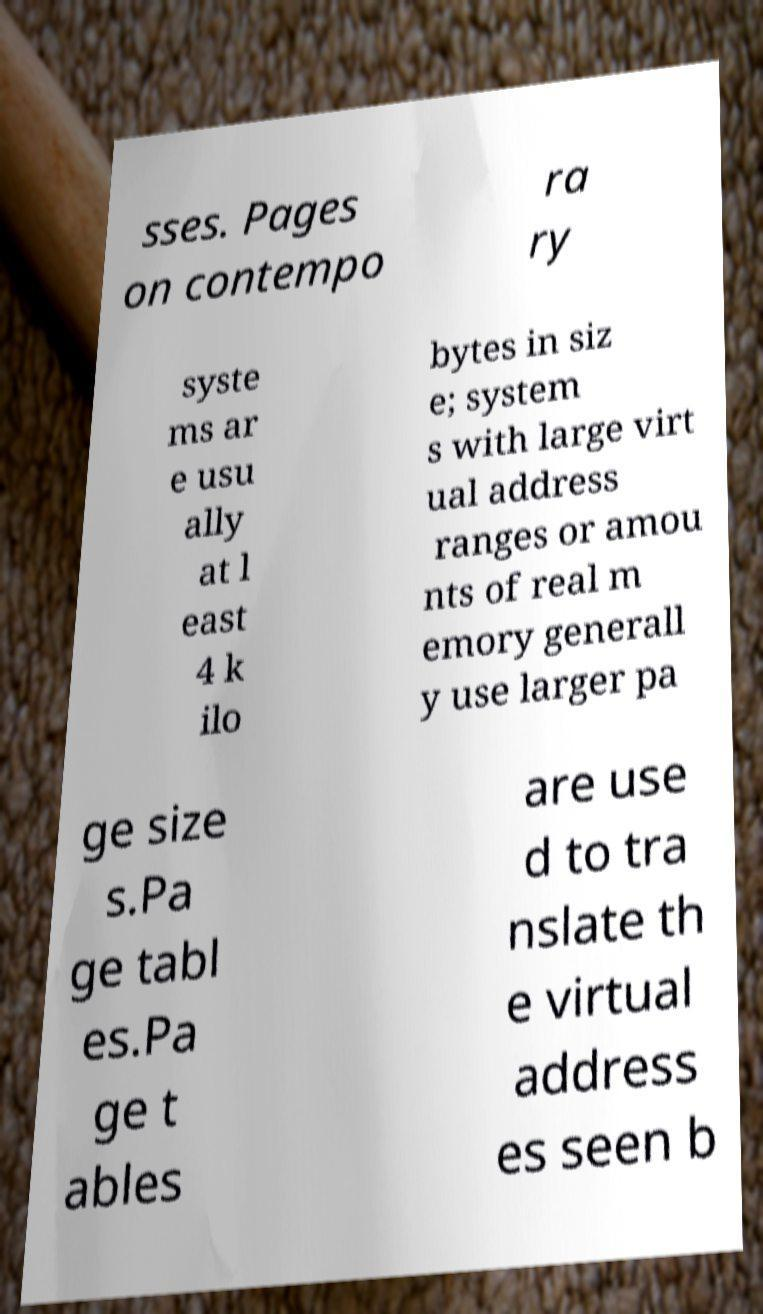Can you accurately transcribe the text from the provided image for me? sses. Pages on contempo ra ry syste ms ar e usu ally at l east 4 k ilo bytes in siz e; system s with large virt ual address ranges or amou nts of real m emory generall y use larger pa ge size s.Pa ge tabl es.Pa ge t ables are use d to tra nslate th e virtual address es seen b 